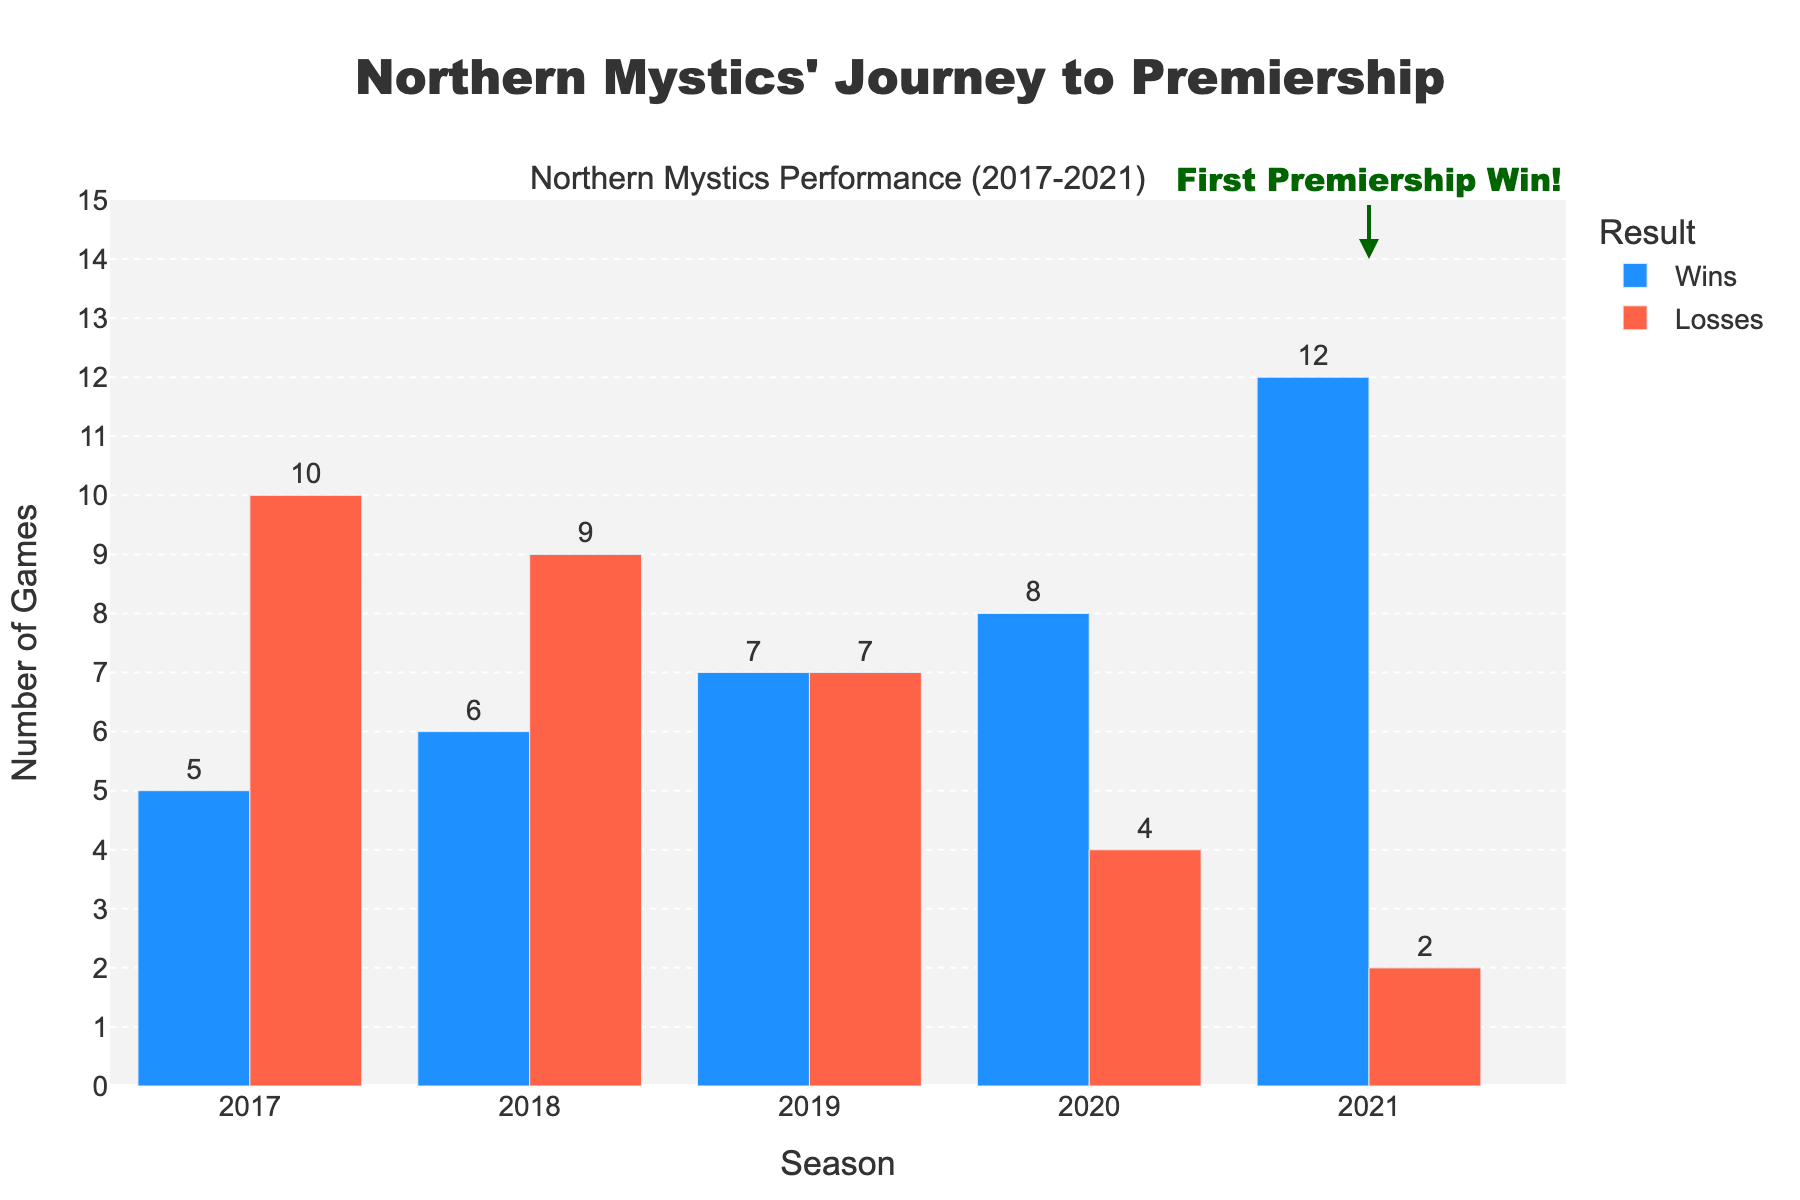Which season had the most wins for the Northern Mystics? By looking at the bar chart, the tallest blue bar representing the wins is for the 2021 season.
Answer: 2021 What is the total number of wins across all seasons? Sum the wins from all seasons: 5 + 6 + 7 + 8 + 12 = 38.
Answer: 38 Which season had the highest number of losses? By observing the red bars, the tallest red bar is for the 2017 season.
Answer: 2017 How many more games did the Northern Mystics win in 2021 compared to 2018? Subtract the number of wins in 2018 from the wins in 2021: 12 - 6 = 6.
Answer: 6 What is the difference in the total number of wins in 2019 and 2020? Subtract the number of wins in 2019 from the wins in 2020: 8 - 7 = 1.
Answer: 1 What is the average number of losses over the 5 seasons? Calculate the average by summing the losses and dividing by 5: (10 + 9 + 7 + 4 + 2) / 5 = 32 / 5 = 6.4.
Answer: 6.4 Which season experienced the largest improvement in wins compared to the previous season? Compare the yearly increase in wins: 2018 to 2019 (7 - 6 = 1), 2019 to 2020 (8 - 7 = 1), 2020 to 2021 (12 - 8 = 4). The largest increase is from 2020 to 2021.
Answer: 2021 How many seasons had more wins than losses? Check each season: 2021 (12 wins > 2 losses), 2020 (8 wins > 4 losses), 2019 (7 wins = 7 losses), 2018 (6 wins < 9 losses), 2017 (5 wins < 10 losses). Thus, 2 seasons had more wins than losses.
Answer: 2 What was the net change in the number of wins from 2017 to 2021? Calculate the difference between wins in 2021 and 2017: 12 - 5 = 7.
Answer: 7 In which season did the Northern Mystics achieve an equal number of wins and losses? By observing the bars, only the 2019 season shows an equal number of wins and losses (7 each).
Answer: 2019 